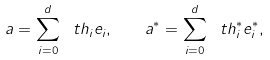<formula> <loc_0><loc_0><loc_500><loc_500>a = \sum _ { i = 0 } ^ { d } \ t h _ { i } e _ { i } , \quad a ^ { * } = \sum _ { i = 0 } ^ { d } \ t h ^ { * } _ { i } e ^ { * } _ { i } ,</formula> 